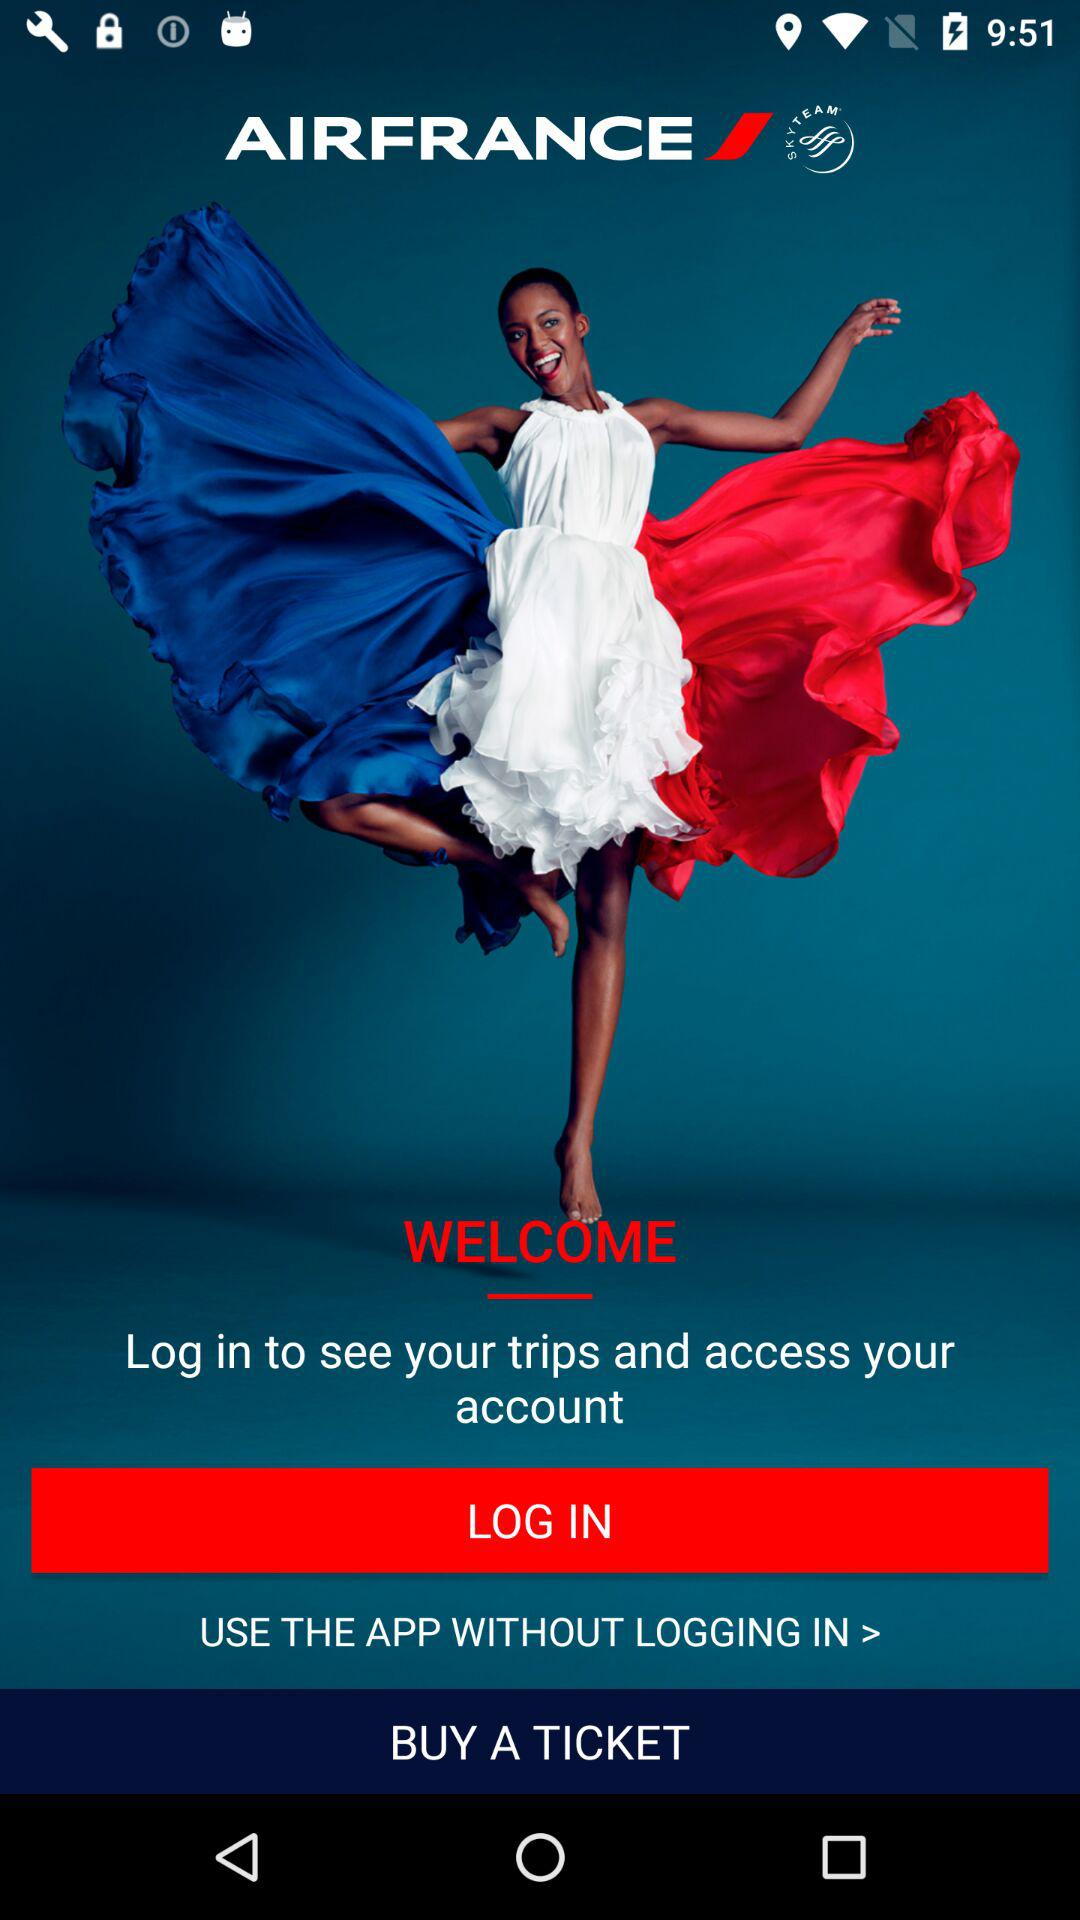How to login without using an application?
When the provided information is insufficient, respond with <no answer>. <no answer> 